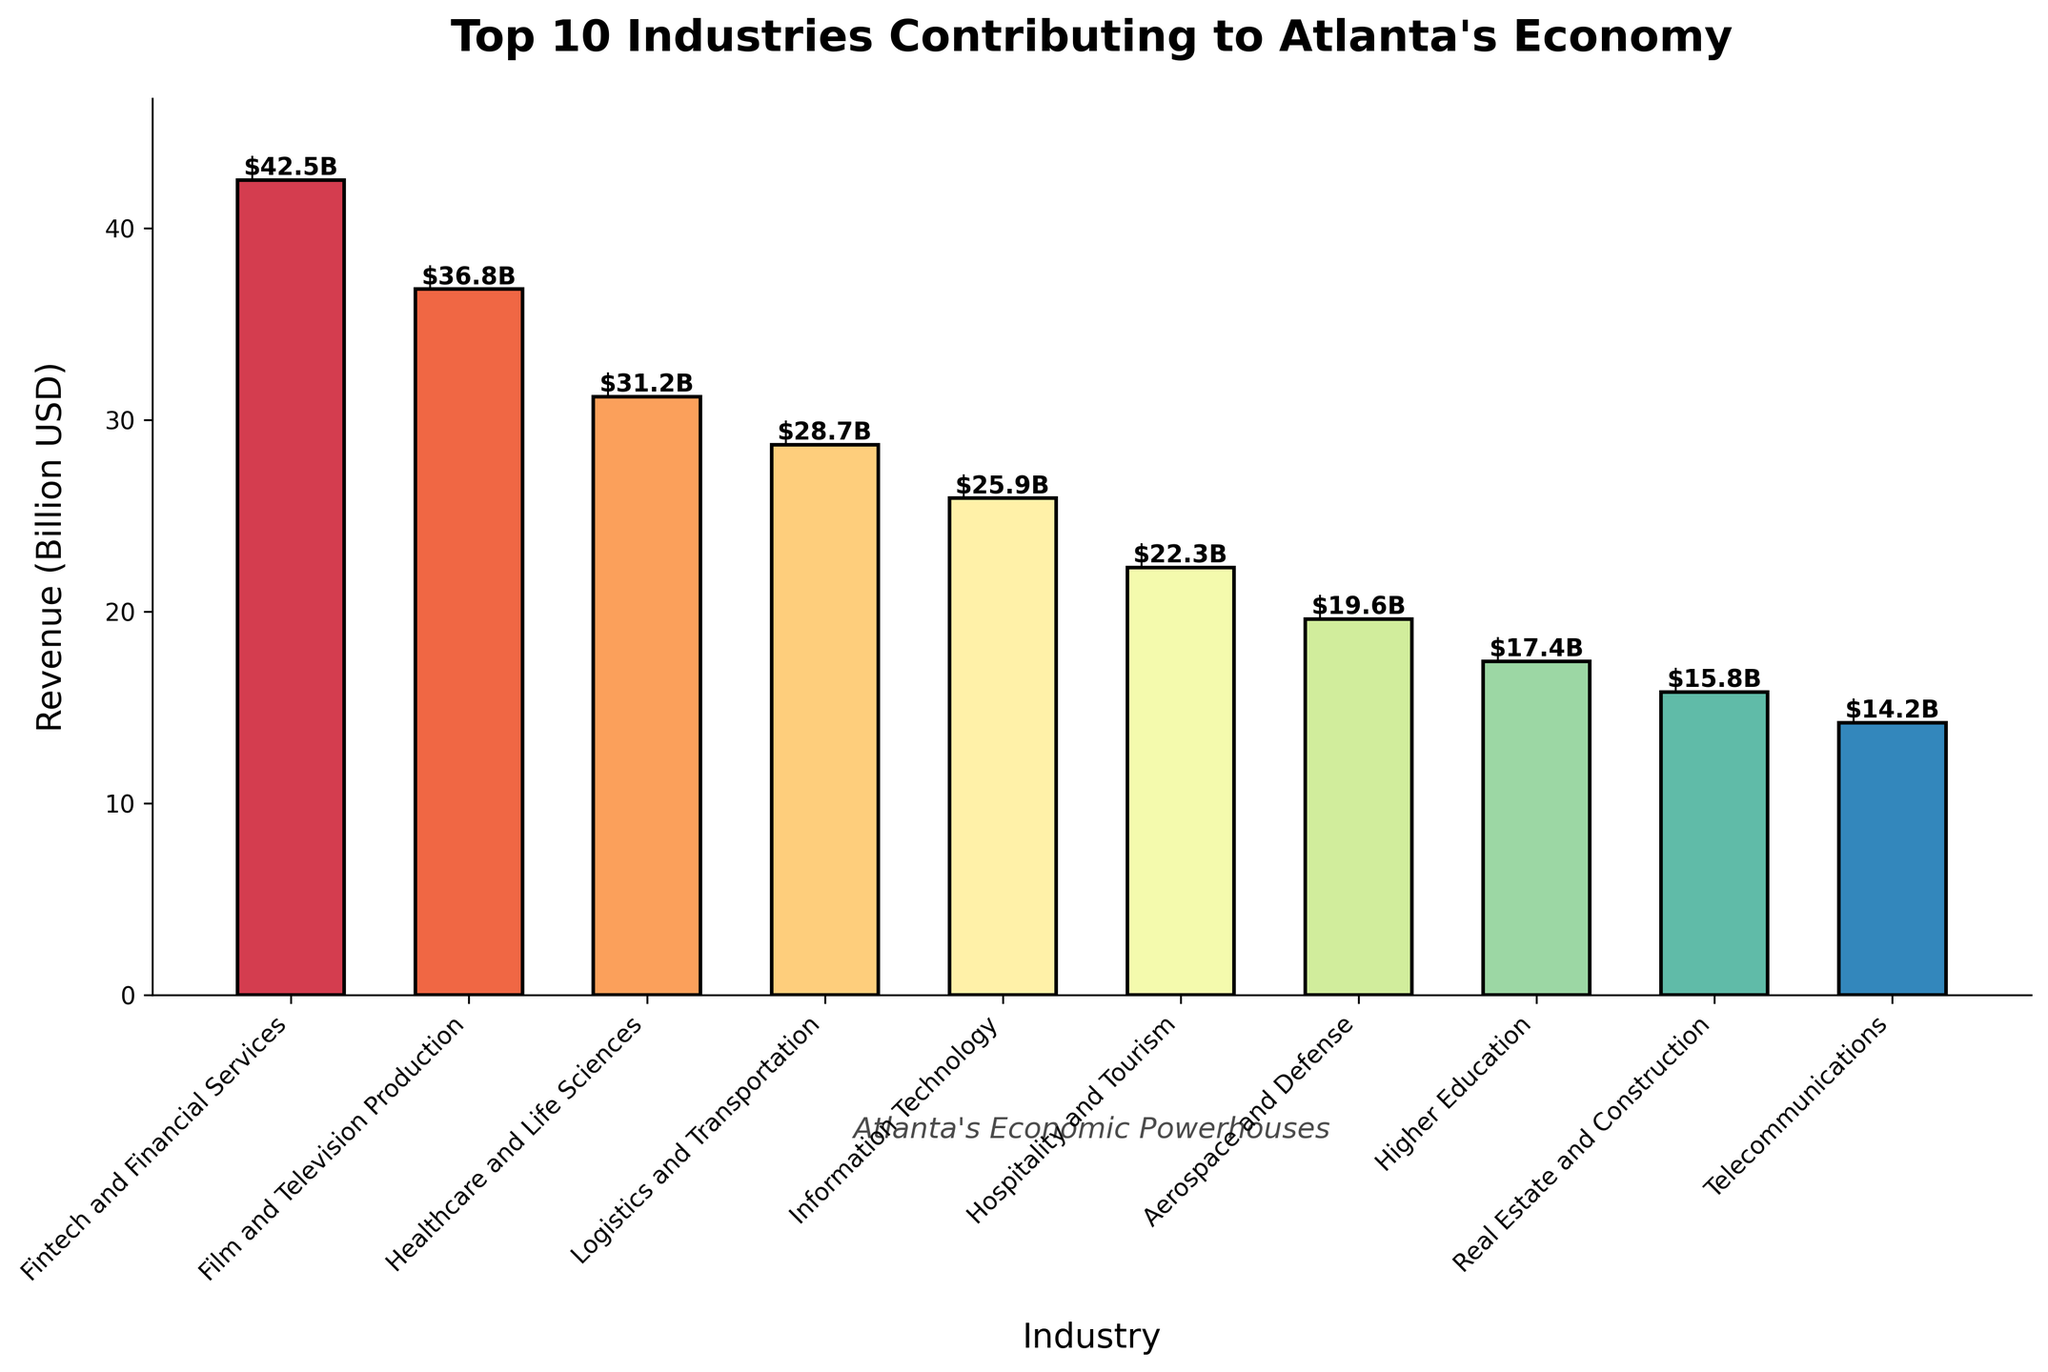What's the industry with the highest revenue? The industry with the highest revenue can be found by identifying the tallest bar. The bar labeled "Fintech and Financial Services" is the tallest.
Answer: Fintech and Financial Services What's the total revenue of the top 3 contributing industries? First, identify the top three industries by their bars' height: "Fintech and Financial Services" ($42.5B), "Film and Television Production" ($36.8B), and "Healthcare and Life Sciences" ($31.2B). Sum these values: $42.5B + $36.8B + $31.2B = $110.5B
Answer: $110.5B How much more revenue does the highest contributing industry make compared to the lowest? The highest value is for "Fintech and Financial Services" ($42.5B) and the lowest is "Telecommunications" ($14.2B). Their difference is $42.5B - $14.2B = $28.3B.
Answer: $28.3B Which industries contribute more than $30 billion each in revenue? By inspecting the bar heights that are above the $30B mark, we find three industries: "Fintech and Financial Services" ($42.5B), "Film and Television Production" ($36.8B), and "Healthcare and Life Sciences" ($31.2B).
Answer: Fintech and Financial Services, Film and Television Production, Healthcare and Life Sciences What's the combined revenue of "Logistics and Transportation" and "Information Technology"? Look at the bar heights for both industries: "Logistics and Transportation" ($28.7B) and "Information Technology" ($25.9B). Sum these values: $28.7B + $25.9B = $54.6B.
Answer: $54.6B Which industry has approximately half the revenue of "Fintech and Financial Services"? "Fintech and Financial Services" has $42.5B in revenue, half of which is $42.5B / 2 = $21.25B. The industry closest to this value is "Hospitality and Tourism" with $22.3B.
Answer: Hospitality and Tourism What are the revenues of the three industries with the shortest bars? Identify the three industries with the shortest bars by inspection, which are: "Telecommunications" ($14.2B), "Real Estate and Construction" ($15.8B), and "Higher Education" ($17.4B).
Answer: $14.2B, $15.8B, $17.4B How much more revenue do "Healthcare and Life Sciences" generate compared to "Higher Education"? The "Healthcare and Life Sciences" industry generates $31.2B while "Higher Education" generates $17.4B. Their difference is $31.2B - $17.4B = $13.8B.
Answer: $13.8B Are there more industries with revenue above or below $20 billion? Count the number of industry bars above $20B: 6 ("Fintech and Financial Services", "Film and Television Production", "Healthcare and Life Sciences", "Logistics and Transportation", "Information Technology", "Hospitality and Tourism"). Count the number below $20B: 4 ("Aerospace and Defense", "Higher Education", "Real Estate and Construction", "Telecommunications"). There are more industries above $20B.
Answer: Above Which industry has the fourth highest revenue and what's its value? By inspecting the bar heights, the fourth highest industry is "Logistics and Transportation" with a revenue of $28.7B.
Answer: Logistics and Transportation, $28.7B 